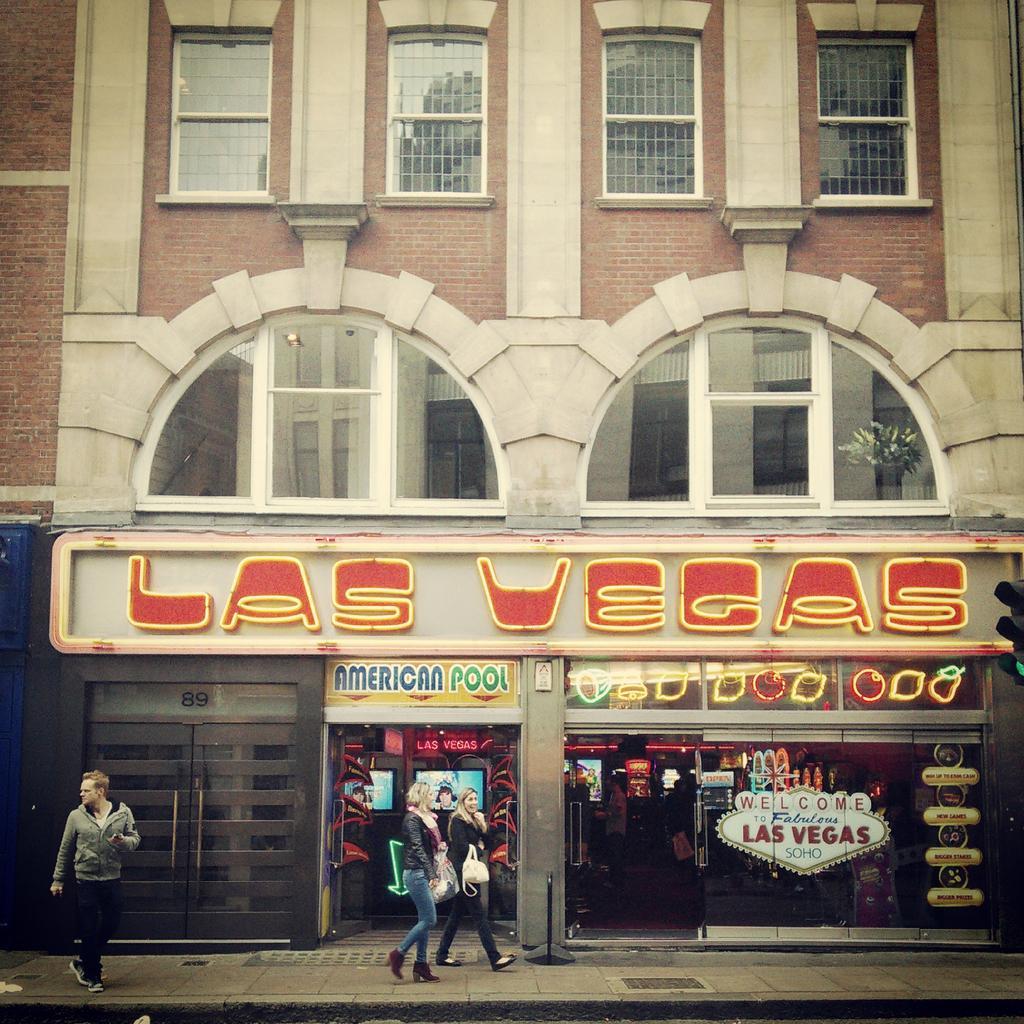Can you describe this image briefly? At the bottom of the picture, we see two women and a man are walking on the footpath. Beside them, we see a building in white and brown color. This building is made up of brown colored bricks. Beside that, we see the glass door and a board in white and yellow color with some text written on it. We see the windows and flower pots. 